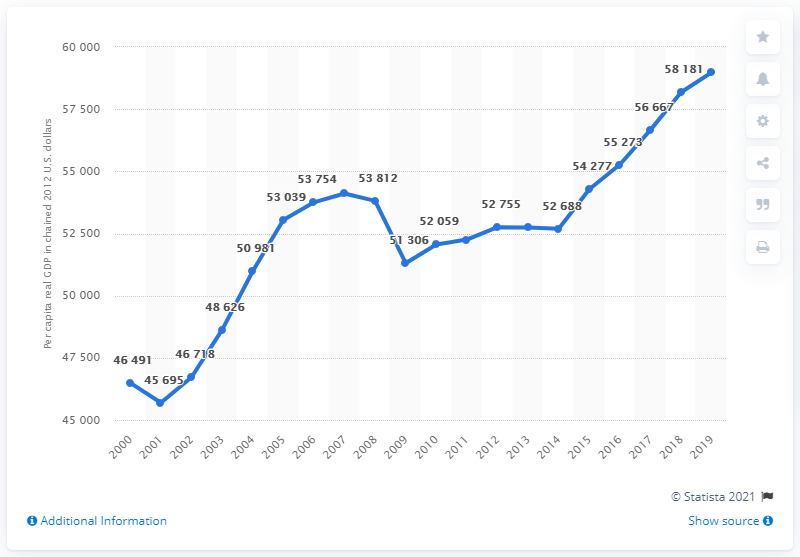Identify some key points in this picture. In 2019, the per capita real GDP of Hawaii was the highest it had been in the year 2000. 